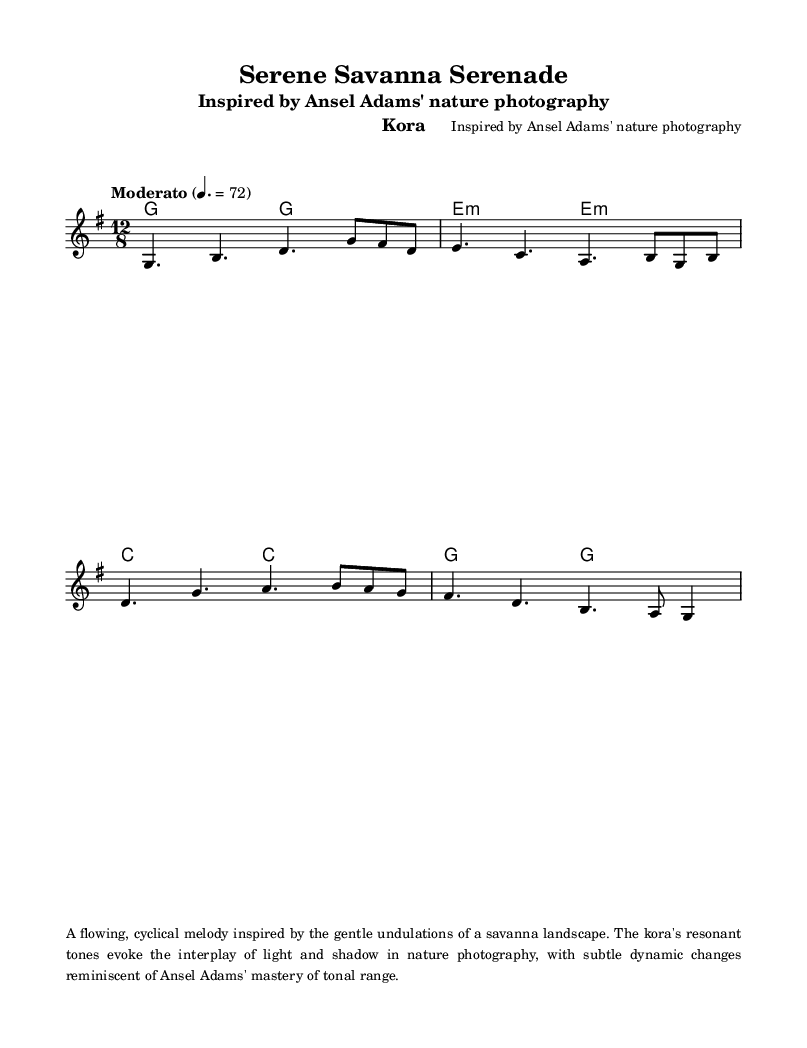What is the key signature of this music? The key signature is indicated at the beginning of the score, showing a G major key, which has one sharp (F#).
Answer: G major What is the time signature of this piece? The time signature is found at the beginning of the score, represented as 12/8, indicating a compound meter which typically feels like four beats per measure, each subdivided into three.
Answer: 12/8 What is the tempo marking for this piece? The tempo marking is specified in the score, which indicates "Moderato" at a speed of 4. = 72, guiding the performer on the pace to maintain.
Answer: Moderato 4. = 72 How many measures are in the melody? By counting each distinct segment in the melody written in the staff, we find there are five measures in total, delineated by the vertical bar lines.
Answer: 5 Identify the first note of the melody. The first note is the first pitch encountered in the melody section, which is a G, as indicated by the notation on the staff.
Answer: G What type of musical form is utilized in the melody? The melody demonstrates a flowing and cyclical nature, characteristic of traditional kora music, which often employs repetition and variation, reflecting the themes of nature.
Answer: Cyclical What instrument is indicated as part of the piece? The instrument specified in the header of the score is a kora, which is a traditional West African string instrument known for its rich, resonant sound.
Answer: Kora 